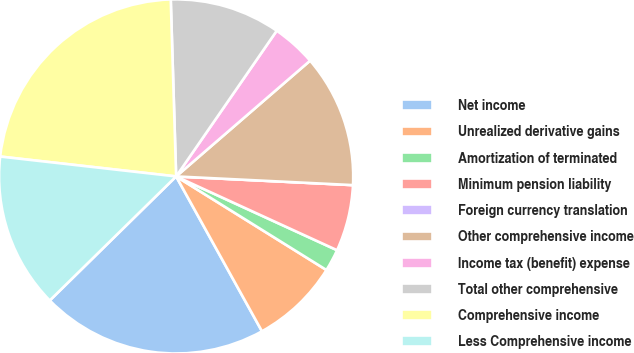Convert chart to OTSL. <chart><loc_0><loc_0><loc_500><loc_500><pie_chart><fcel>Net income<fcel>Unrealized derivative gains<fcel>Amortization of terminated<fcel>Minimum pension liability<fcel>Foreign currency translation<fcel>Other comprehensive income<fcel>Income tax (benefit) expense<fcel>Total other comprehensive<fcel>Comprehensive income<fcel>Less Comprehensive income<nl><fcel>20.7%<fcel>8.08%<fcel>2.02%<fcel>6.06%<fcel>0.0%<fcel>12.12%<fcel>4.04%<fcel>10.1%<fcel>22.72%<fcel>14.14%<nl></chart> 